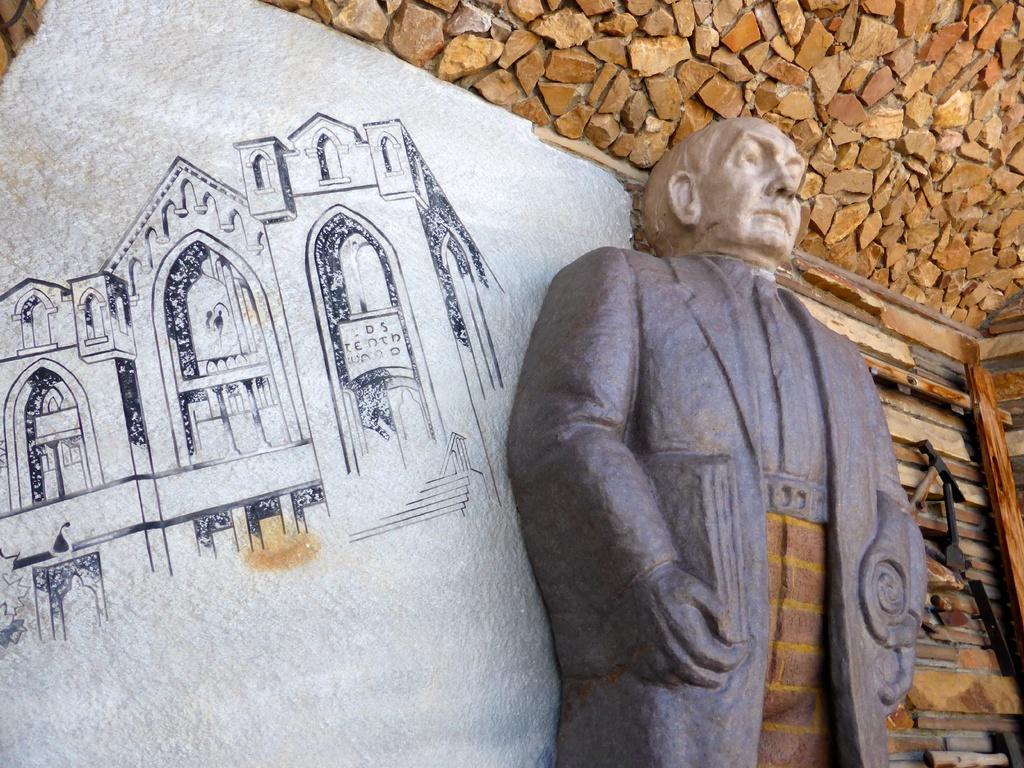Describe this image in one or two sentences. In this image there is a person statue. Behind there is a rock wall. Left side a building picture is painted on the wall. Right side few objects are on the wall. 